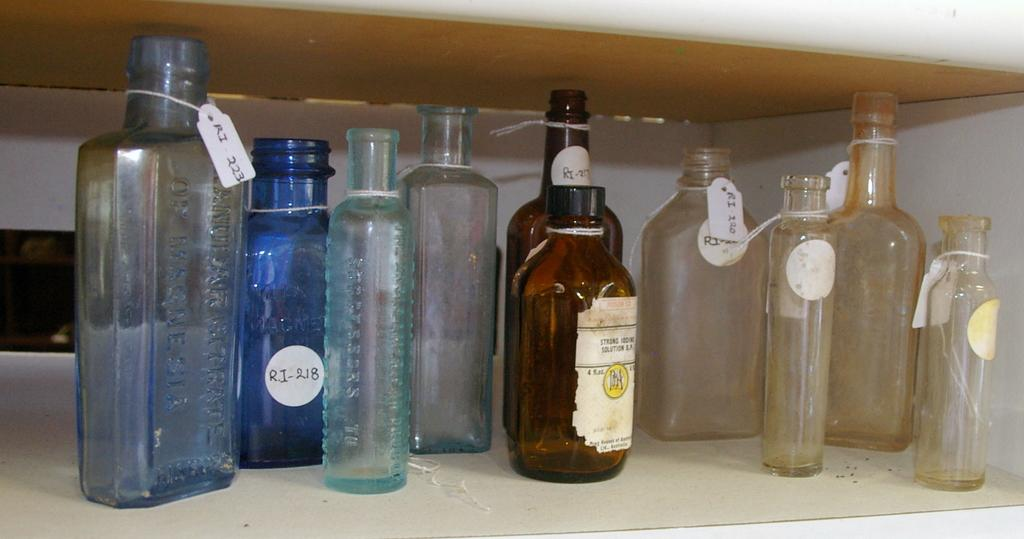<image>
Render a clear and concise summary of the photo. A set of empty antique bottles includes one labeled "strong iodine solution". 